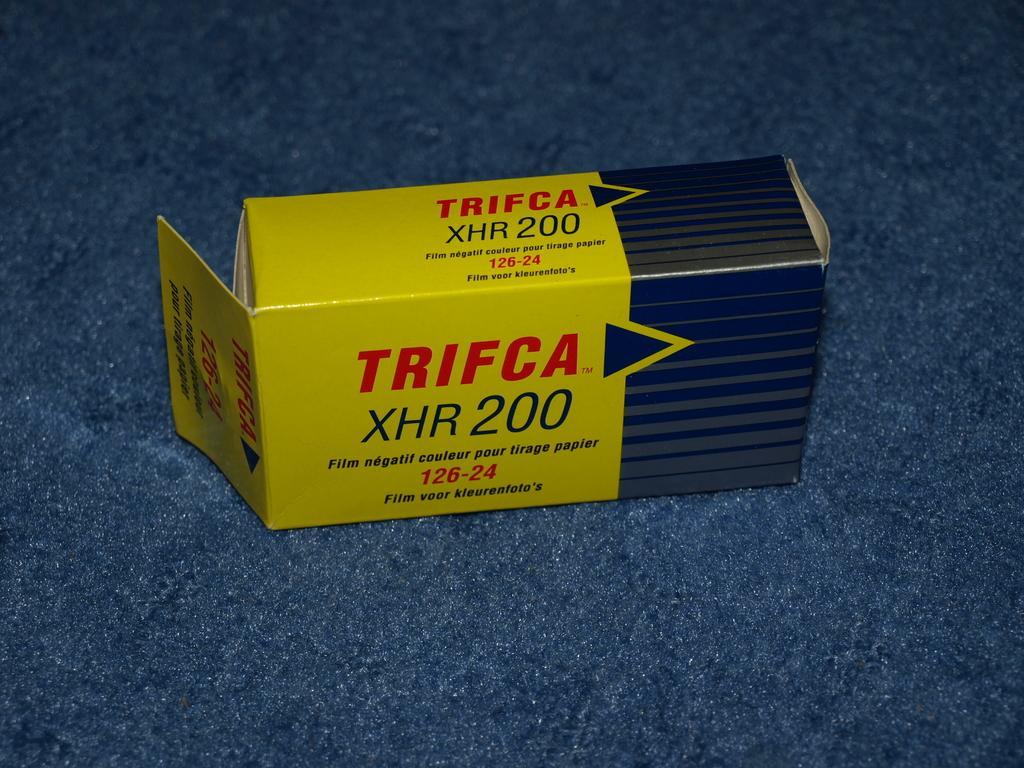Can you describe this image briefly? In this image we can see a box with some text and numbers on it, which is on the blue colored surface. 